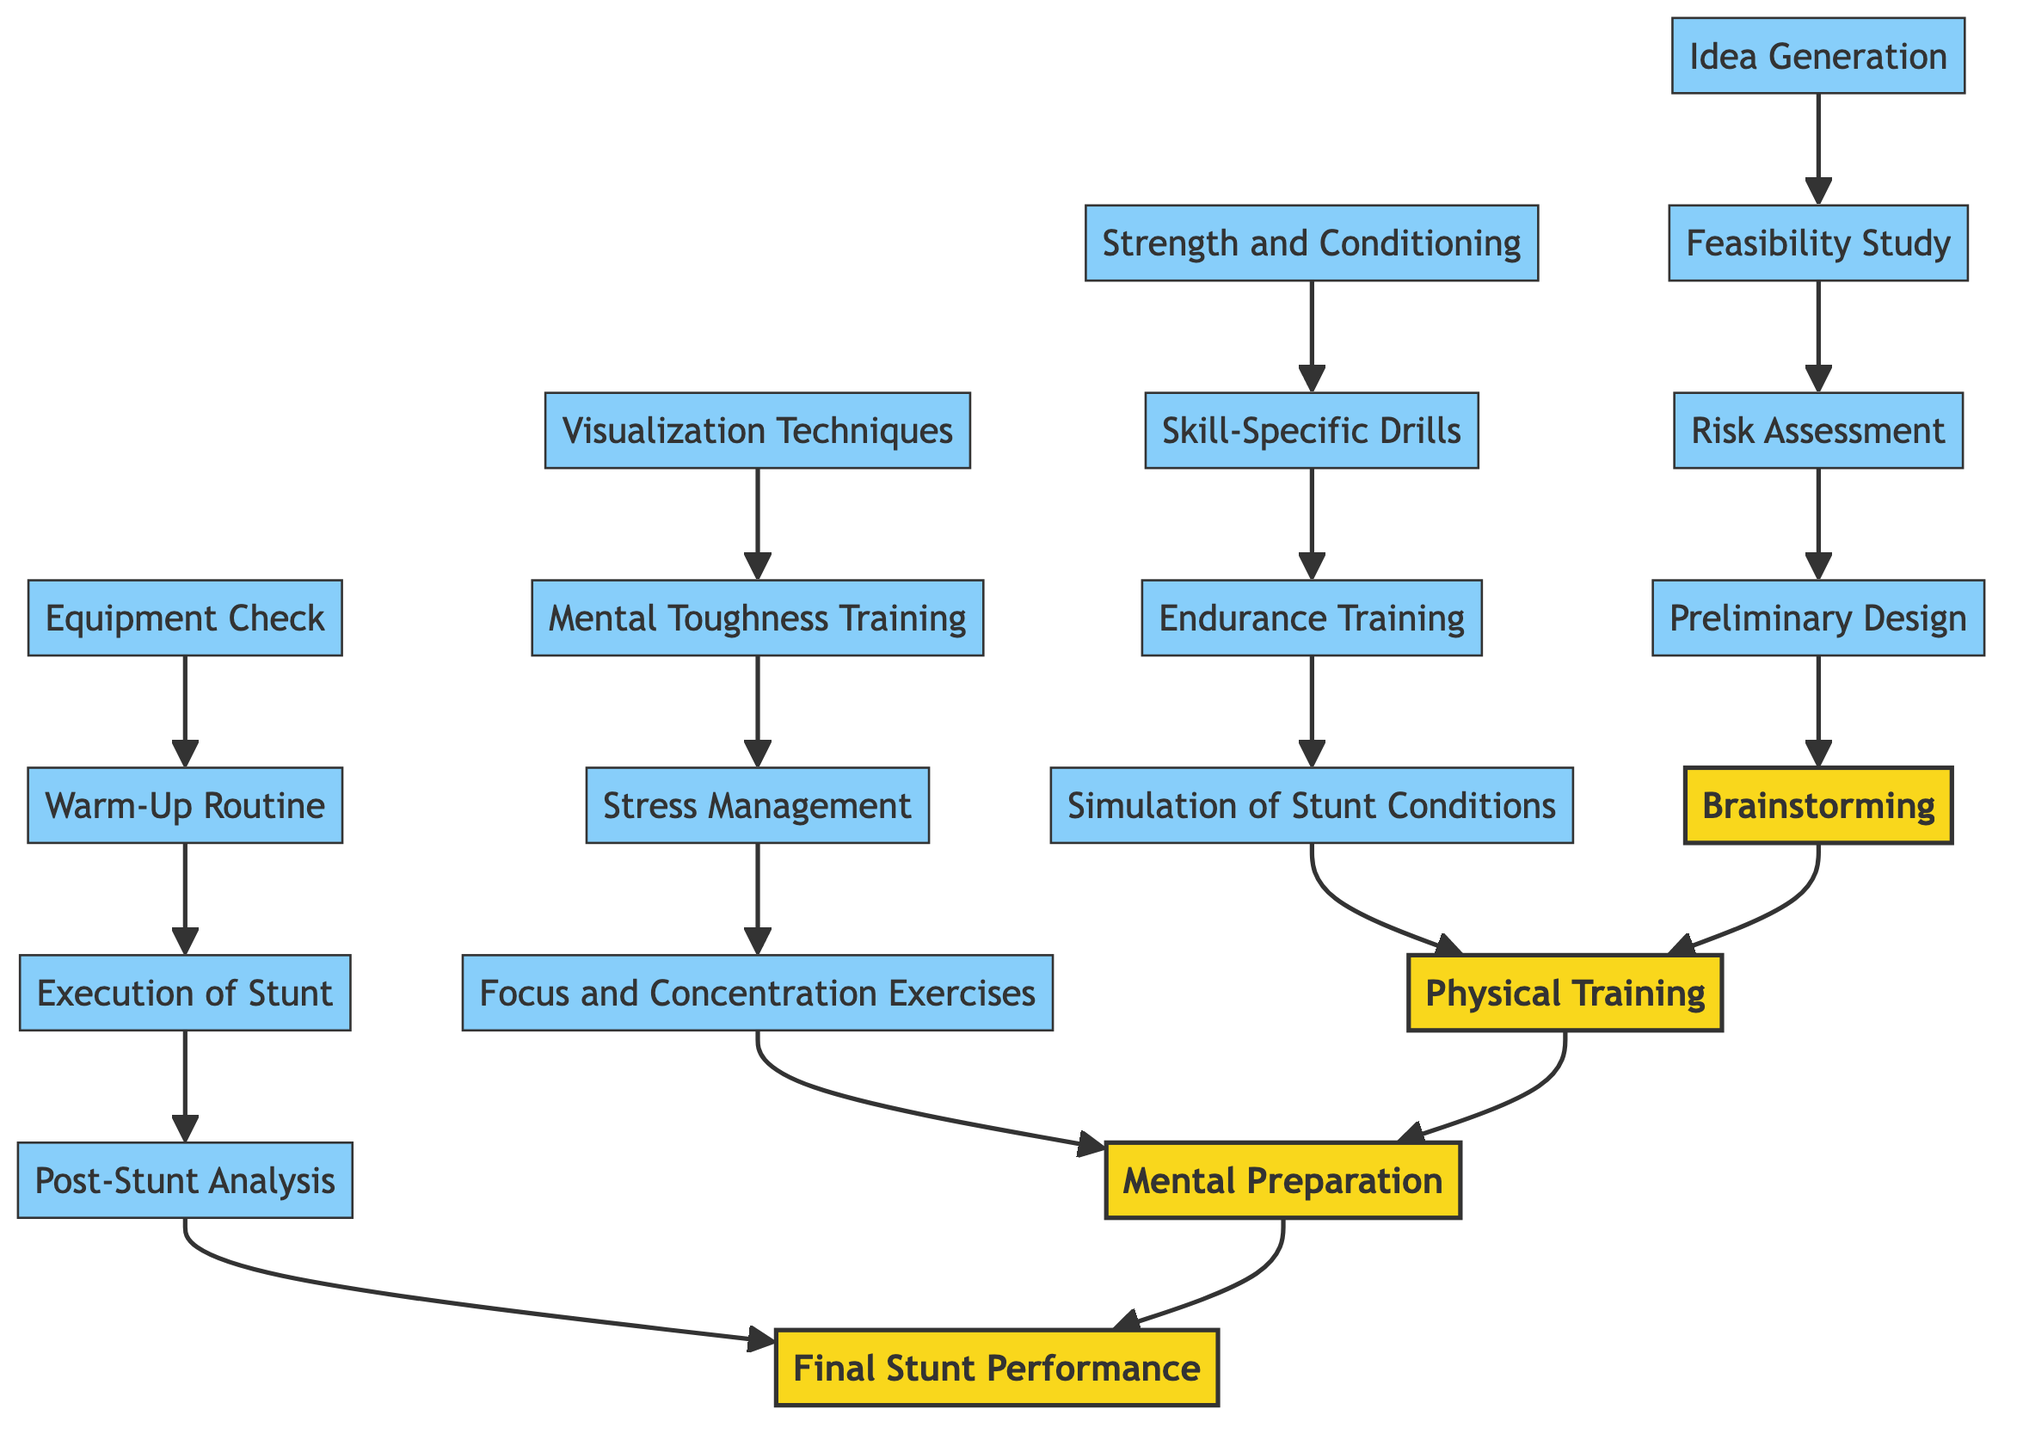What are the four main stages in this training progression? The four main stages listed in the diagram are: Brainstorming, Physical Training, Mental Preparation, and Final Stunt Performance. These stages are clearly defined and presented from the bottom to the top of the flowchart.
Answer: Brainstorming, Physical Training, Mental Preparation, Final Stunt Performance How many details are included in the Mental Preparation stage? The Mental Preparation stage includes four detailed steps: Visualization Techniques, Mental Toughness Training, Stress Management, and Focus and Concentration Exercises. These details are listed under the Mental Preparation node in the diagram.
Answer: 4 What is the first step in the Physical Training stage? The first step indicated in the Physical Training stage is Strength and Conditioning. The diagram shows this as the first node in the upward flow to the Physical Training node, indicating its position as the primary focus.
Answer: Strength and Conditioning Which stage leads to Final Stunt Performance? The stage that leads directly to Final Stunt Performance is Mental Preparation. The upward arrows connect these two stages, showing that Mental Preparation is concluded before proceeding to the execution of the stunt.
Answer: Mental Preparation List one detail from the Brainstorming stage. One of the details in the Brainstorming stage is Idea Generation. This is one of the foundational components necessary for the beginning of the training progression, as indicated by the details listed under the Brainstorming node.
Answer: Idea Generation What is the last step in the Final Stunt Performance stage? The last step in the Final Stunt Performance stage is Post-Stunt Analysis. This step is placed at the bottom of the Fourth stage in the diagram as the concluding component of the overall progression.
Answer: Post-Stunt Analysis Which two stages are adjacent in the flowchart? The two stages that are adjacent in the flowchart are Physical Training and Mental Preparation. The diagram shows the sequential flow from Physical Training directly upwards to Mental Preparation without any intervening stages.
Answer: Physical Training, Mental Preparation 